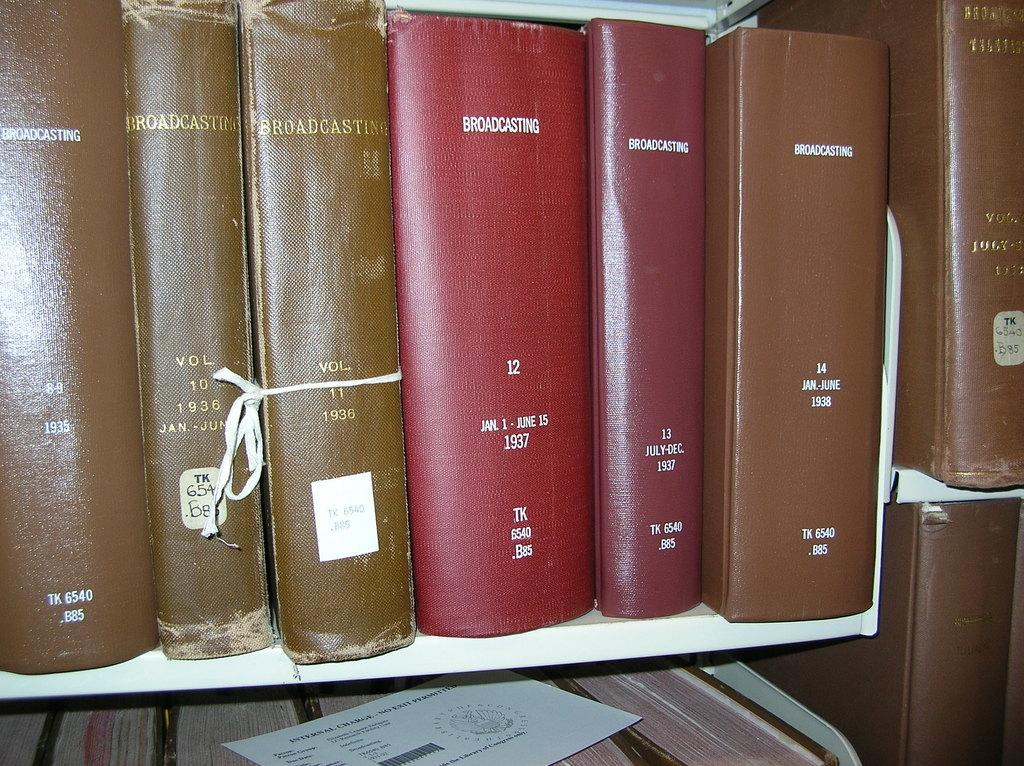<image>
Summarize the visual content of the image. Rows of books with the word Broadcasting printed across each of them. 